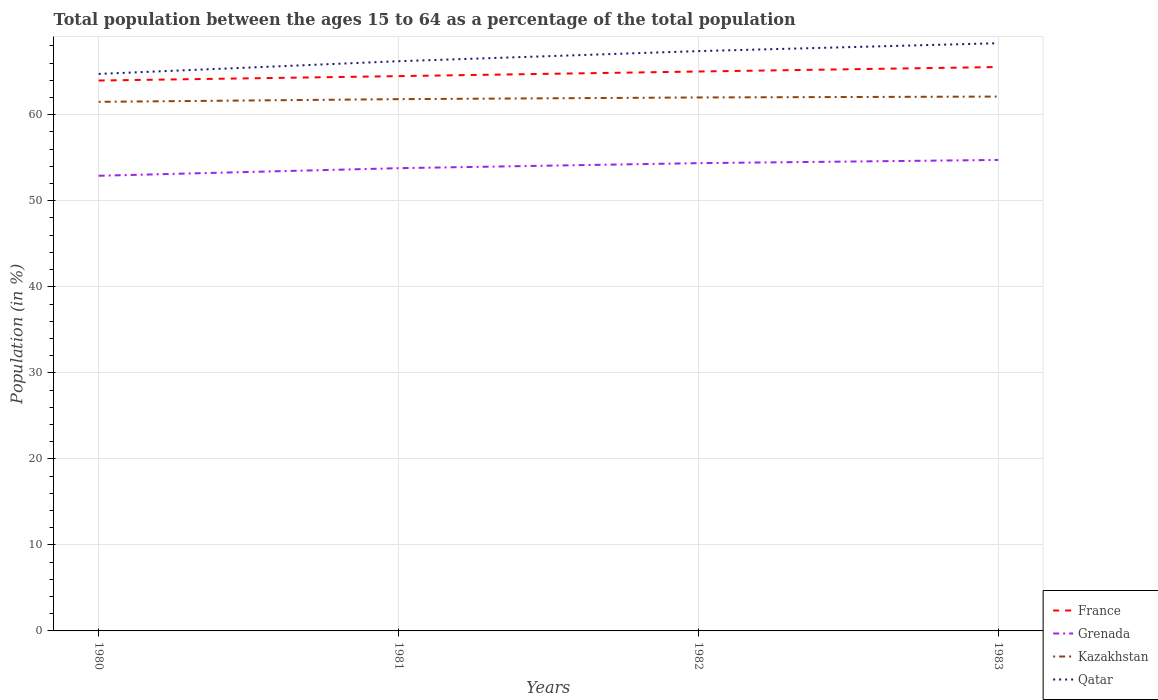Is the number of lines equal to the number of legend labels?
Provide a short and direct response. Yes. Across all years, what is the maximum percentage of the population ages 15 to 64 in Kazakhstan?
Your response must be concise. 61.5. In which year was the percentage of the population ages 15 to 64 in Kazakhstan maximum?
Offer a terse response. 1980. What is the total percentage of the population ages 15 to 64 in Kazakhstan in the graph?
Give a very brief answer. -0.2. What is the difference between the highest and the second highest percentage of the population ages 15 to 64 in Qatar?
Provide a short and direct response. 3.57. Does the graph contain any zero values?
Ensure brevity in your answer.  No. Does the graph contain grids?
Provide a short and direct response. Yes. Where does the legend appear in the graph?
Your response must be concise. Bottom right. How many legend labels are there?
Ensure brevity in your answer.  4. What is the title of the graph?
Offer a terse response. Total population between the ages 15 to 64 as a percentage of the total population. Does "Portugal" appear as one of the legend labels in the graph?
Keep it short and to the point. No. What is the Population (in %) in France in 1980?
Keep it short and to the point. 63.98. What is the Population (in %) in Grenada in 1980?
Provide a short and direct response. 52.91. What is the Population (in %) of Kazakhstan in 1980?
Make the answer very short. 61.5. What is the Population (in %) of Qatar in 1980?
Your response must be concise. 64.75. What is the Population (in %) of France in 1981?
Provide a short and direct response. 64.49. What is the Population (in %) in Grenada in 1981?
Ensure brevity in your answer.  53.79. What is the Population (in %) in Kazakhstan in 1981?
Offer a terse response. 61.81. What is the Population (in %) of Qatar in 1981?
Offer a terse response. 66.22. What is the Population (in %) of France in 1982?
Your answer should be very brief. 65.03. What is the Population (in %) in Grenada in 1982?
Your answer should be compact. 54.37. What is the Population (in %) of Kazakhstan in 1982?
Offer a terse response. 62.01. What is the Population (in %) in Qatar in 1982?
Your answer should be very brief. 67.4. What is the Population (in %) in France in 1983?
Your answer should be very brief. 65.55. What is the Population (in %) of Grenada in 1983?
Offer a very short reply. 54.75. What is the Population (in %) in Kazakhstan in 1983?
Provide a short and direct response. 62.11. What is the Population (in %) in Qatar in 1983?
Your answer should be very brief. 68.32. Across all years, what is the maximum Population (in %) in France?
Give a very brief answer. 65.55. Across all years, what is the maximum Population (in %) in Grenada?
Offer a terse response. 54.75. Across all years, what is the maximum Population (in %) in Kazakhstan?
Make the answer very short. 62.11. Across all years, what is the maximum Population (in %) of Qatar?
Offer a terse response. 68.32. Across all years, what is the minimum Population (in %) in France?
Keep it short and to the point. 63.98. Across all years, what is the minimum Population (in %) in Grenada?
Offer a terse response. 52.91. Across all years, what is the minimum Population (in %) in Kazakhstan?
Your answer should be compact. 61.5. Across all years, what is the minimum Population (in %) in Qatar?
Your answer should be very brief. 64.75. What is the total Population (in %) in France in the graph?
Your response must be concise. 259.04. What is the total Population (in %) in Grenada in the graph?
Keep it short and to the point. 215.82. What is the total Population (in %) in Kazakhstan in the graph?
Provide a succinct answer. 247.44. What is the total Population (in %) in Qatar in the graph?
Provide a short and direct response. 266.69. What is the difference between the Population (in %) of France in 1980 and that in 1981?
Your answer should be very brief. -0.51. What is the difference between the Population (in %) in Grenada in 1980 and that in 1981?
Your answer should be very brief. -0.88. What is the difference between the Population (in %) of Kazakhstan in 1980 and that in 1981?
Provide a succinct answer. -0.31. What is the difference between the Population (in %) in Qatar in 1980 and that in 1981?
Your answer should be very brief. -1.48. What is the difference between the Population (in %) in France in 1980 and that in 1982?
Give a very brief answer. -1.05. What is the difference between the Population (in %) of Grenada in 1980 and that in 1982?
Offer a very short reply. -1.47. What is the difference between the Population (in %) in Kazakhstan in 1980 and that in 1982?
Offer a very short reply. -0.51. What is the difference between the Population (in %) of Qatar in 1980 and that in 1982?
Your response must be concise. -2.65. What is the difference between the Population (in %) of France in 1980 and that in 1983?
Your response must be concise. -1.57. What is the difference between the Population (in %) of Grenada in 1980 and that in 1983?
Ensure brevity in your answer.  -1.84. What is the difference between the Population (in %) in Kazakhstan in 1980 and that in 1983?
Make the answer very short. -0.61. What is the difference between the Population (in %) of Qatar in 1980 and that in 1983?
Provide a succinct answer. -3.57. What is the difference between the Population (in %) of France in 1981 and that in 1982?
Keep it short and to the point. -0.54. What is the difference between the Population (in %) of Grenada in 1981 and that in 1982?
Your response must be concise. -0.59. What is the difference between the Population (in %) in Kazakhstan in 1981 and that in 1982?
Your response must be concise. -0.2. What is the difference between the Population (in %) of Qatar in 1981 and that in 1982?
Make the answer very short. -1.17. What is the difference between the Population (in %) of France in 1981 and that in 1983?
Provide a succinct answer. -1.06. What is the difference between the Population (in %) of Grenada in 1981 and that in 1983?
Offer a very short reply. -0.96. What is the difference between the Population (in %) of Kazakhstan in 1981 and that in 1983?
Your answer should be very brief. -0.3. What is the difference between the Population (in %) in Qatar in 1981 and that in 1983?
Your answer should be very brief. -2.09. What is the difference between the Population (in %) of France in 1982 and that in 1983?
Give a very brief answer. -0.52. What is the difference between the Population (in %) of Grenada in 1982 and that in 1983?
Offer a terse response. -0.37. What is the difference between the Population (in %) in Kazakhstan in 1982 and that in 1983?
Offer a very short reply. -0.1. What is the difference between the Population (in %) of Qatar in 1982 and that in 1983?
Give a very brief answer. -0.92. What is the difference between the Population (in %) of France in 1980 and the Population (in %) of Grenada in 1981?
Your answer should be compact. 10.19. What is the difference between the Population (in %) in France in 1980 and the Population (in %) in Kazakhstan in 1981?
Provide a short and direct response. 2.16. What is the difference between the Population (in %) in France in 1980 and the Population (in %) in Qatar in 1981?
Make the answer very short. -2.25. What is the difference between the Population (in %) in Grenada in 1980 and the Population (in %) in Kazakhstan in 1981?
Keep it short and to the point. -8.91. What is the difference between the Population (in %) of Grenada in 1980 and the Population (in %) of Qatar in 1981?
Provide a succinct answer. -13.32. What is the difference between the Population (in %) of Kazakhstan in 1980 and the Population (in %) of Qatar in 1981?
Make the answer very short. -4.72. What is the difference between the Population (in %) in France in 1980 and the Population (in %) in Grenada in 1982?
Make the answer very short. 9.6. What is the difference between the Population (in %) of France in 1980 and the Population (in %) of Kazakhstan in 1982?
Keep it short and to the point. 1.97. What is the difference between the Population (in %) in France in 1980 and the Population (in %) in Qatar in 1982?
Keep it short and to the point. -3.42. What is the difference between the Population (in %) in Grenada in 1980 and the Population (in %) in Kazakhstan in 1982?
Your response must be concise. -9.1. What is the difference between the Population (in %) of Grenada in 1980 and the Population (in %) of Qatar in 1982?
Your answer should be very brief. -14.49. What is the difference between the Population (in %) of Kazakhstan in 1980 and the Population (in %) of Qatar in 1982?
Your answer should be compact. -5.9. What is the difference between the Population (in %) in France in 1980 and the Population (in %) in Grenada in 1983?
Your answer should be compact. 9.23. What is the difference between the Population (in %) in France in 1980 and the Population (in %) in Kazakhstan in 1983?
Provide a short and direct response. 1.86. What is the difference between the Population (in %) in France in 1980 and the Population (in %) in Qatar in 1983?
Your answer should be compact. -4.34. What is the difference between the Population (in %) in Grenada in 1980 and the Population (in %) in Kazakhstan in 1983?
Your response must be concise. -9.21. What is the difference between the Population (in %) in Grenada in 1980 and the Population (in %) in Qatar in 1983?
Offer a very short reply. -15.41. What is the difference between the Population (in %) in Kazakhstan in 1980 and the Population (in %) in Qatar in 1983?
Keep it short and to the point. -6.81. What is the difference between the Population (in %) of France in 1981 and the Population (in %) of Grenada in 1982?
Provide a short and direct response. 10.12. What is the difference between the Population (in %) in France in 1981 and the Population (in %) in Kazakhstan in 1982?
Give a very brief answer. 2.48. What is the difference between the Population (in %) in France in 1981 and the Population (in %) in Qatar in 1982?
Make the answer very short. -2.91. What is the difference between the Population (in %) of Grenada in 1981 and the Population (in %) of Kazakhstan in 1982?
Provide a succinct answer. -8.22. What is the difference between the Population (in %) of Grenada in 1981 and the Population (in %) of Qatar in 1982?
Your answer should be very brief. -13.61. What is the difference between the Population (in %) of Kazakhstan in 1981 and the Population (in %) of Qatar in 1982?
Offer a very short reply. -5.58. What is the difference between the Population (in %) of France in 1981 and the Population (in %) of Grenada in 1983?
Provide a short and direct response. 9.74. What is the difference between the Population (in %) in France in 1981 and the Population (in %) in Kazakhstan in 1983?
Your response must be concise. 2.38. What is the difference between the Population (in %) in France in 1981 and the Population (in %) in Qatar in 1983?
Provide a short and direct response. -3.83. What is the difference between the Population (in %) in Grenada in 1981 and the Population (in %) in Kazakhstan in 1983?
Provide a short and direct response. -8.32. What is the difference between the Population (in %) of Grenada in 1981 and the Population (in %) of Qatar in 1983?
Your response must be concise. -14.53. What is the difference between the Population (in %) of Kazakhstan in 1981 and the Population (in %) of Qatar in 1983?
Offer a terse response. -6.5. What is the difference between the Population (in %) in France in 1982 and the Population (in %) in Grenada in 1983?
Your answer should be compact. 10.28. What is the difference between the Population (in %) of France in 1982 and the Population (in %) of Kazakhstan in 1983?
Keep it short and to the point. 2.91. What is the difference between the Population (in %) of France in 1982 and the Population (in %) of Qatar in 1983?
Provide a short and direct response. -3.29. What is the difference between the Population (in %) of Grenada in 1982 and the Population (in %) of Kazakhstan in 1983?
Keep it short and to the point. -7.74. What is the difference between the Population (in %) in Grenada in 1982 and the Population (in %) in Qatar in 1983?
Make the answer very short. -13.94. What is the difference between the Population (in %) of Kazakhstan in 1982 and the Population (in %) of Qatar in 1983?
Keep it short and to the point. -6.31. What is the average Population (in %) of France per year?
Make the answer very short. 64.76. What is the average Population (in %) of Grenada per year?
Your answer should be compact. 53.95. What is the average Population (in %) in Kazakhstan per year?
Your response must be concise. 61.86. What is the average Population (in %) in Qatar per year?
Offer a very short reply. 66.67. In the year 1980, what is the difference between the Population (in %) in France and Population (in %) in Grenada?
Ensure brevity in your answer.  11.07. In the year 1980, what is the difference between the Population (in %) in France and Population (in %) in Kazakhstan?
Make the answer very short. 2.48. In the year 1980, what is the difference between the Population (in %) in France and Population (in %) in Qatar?
Offer a terse response. -0.77. In the year 1980, what is the difference between the Population (in %) in Grenada and Population (in %) in Kazakhstan?
Make the answer very short. -8.6. In the year 1980, what is the difference between the Population (in %) in Grenada and Population (in %) in Qatar?
Provide a short and direct response. -11.84. In the year 1980, what is the difference between the Population (in %) in Kazakhstan and Population (in %) in Qatar?
Offer a very short reply. -3.24. In the year 1981, what is the difference between the Population (in %) in France and Population (in %) in Grenada?
Offer a terse response. 10.7. In the year 1981, what is the difference between the Population (in %) of France and Population (in %) of Kazakhstan?
Your answer should be very brief. 2.68. In the year 1981, what is the difference between the Population (in %) in France and Population (in %) in Qatar?
Your answer should be very brief. -1.73. In the year 1981, what is the difference between the Population (in %) in Grenada and Population (in %) in Kazakhstan?
Your answer should be compact. -8.02. In the year 1981, what is the difference between the Population (in %) of Grenada and Population (in %) of Qatar?
Ensure brevity in your answer.  -12.43. In the year 1981, what is the difference between the Population (in %) of Kazakhstan and Population (in %) of Qatar?
Provide a succinct answer. -4.41. In the year 1982, what is the difference between the Population (in %) in France and Population (in %) in Grenada?
Offer a terse response. 10.65. In the year 1982, what is the difference between the Population (in %) of France and Population (in %) of Kazakhstan?
Offer a terse response. 3.02. In the year 1982, what is the difference between the Population (in %) of France and Population (in %) of Qatar?
Offer a very short reply. -2.37. In the year 1982, what is the difference between the Population (in %) of Grenada and Population (in %) of Kazakhstan?
Give a very brief answer. -7.64. In the year 1982, what is the difference between the Population (in %) of Grenada and Population (in %) of Qatar?
Provide a succinct answer. -13.02. In the year 1982, what is the difference between the Population (in %) in Kazakhstan and Population (in %) in Qatar?
Ensure brevity in your answer.  -5.39. In the year 1983, what is the difference between the Population (in %) in France and Population (in %) in Grenada?
Your answer should be compact. 10.8. In the year 1983, what is the difference between the Population (in %) of France and Population (in %) of Kazakhstan?
Provide a succinct answer. 3.43. In the year 1983, what is the difference between the Population (in %) of France and Population (in %) of Qatar?
Offer a terse response. -2.77. In the year 1983, what is the difference between the Population (in %) in Grenada and Population (in %) in Kazakhstan?
Provide a short and direct response. -7.37. In the year 1983, what is the difference between the Population (in %) of Grenada and Population (in %) of Qatar?
Provide a short and direct response. -13.57. In the year 1983, what is the difference between the Population (in %) of Kazakhstan and Population (in %) of Qatar?
Your answer should be very brief. -6.2. What is the ratio of the Population (in %) in France in 1980 to that in 1981?
Keep it short and to the point. 0.99. What is the ratio of the Population (in %) in Grenada in 1980 to that in 1981?
Keep it short and to the point. 0.98. What is the ratio of the Population (in %) of Qatar in 1980 to that in 1981?
Your response must be concise. 0.98. What is the ratio of the Population (in %) of France in 1980 to that in 1982?
Provide a succinct answer. 0.98. What is the ratio of the Population (in %) of Grenada in 1980 to that in 1982?
Your answer should be very brief. 0.97. What is the ratio of the Population (in %) in Kazakhstan in 1980 to that in 1982?
Your answer should be very brief. 0.99. What is the ratio of the Population (in %) in Qatar in 1980 to that in 1982?
Your answer should be compact. 0.96. What is the ratio of the Population (in %) of France in 1980 to that in 1983?
Make the answer very short. 0.98. What is the ratio of the Population (in %) of Grenada in 1980 to that in 1983?
Offer a very short reply. 0.97. What is the ratio of the Population (in %) of Kazakhstan in 1980 to that in 1983?
Ensure brevity in your answer.  0.99. What is the ratio of the Population (in %) in Qatar in 1980 to that in 1983?
Make the answer very short. 0.95. What is the ratio of the Population (in %) of Qatar in 1981 to that in 1982?
Give a very brief answer. 0.98. What is the ratio of the Population (in %) in France in 1981 to that in 1983?
Your answer should be compact. 0.98. What is the ratio of the Population (in %) in Grenada in 1981 to that in 1983?
Offer a very short reply. 0.98. What is the ratio of the Population (in %) in Kazakhstan in 1981 to that in 1983?
Your answer should be compact. 1. What is the ratio of the Population (in %) of Qatar in 1981 to that in 1983?
Offer a terse response. 0.97. What is the ratio of the Population (in %) in France in 1982 to that in 1983?
Your answer should be very brief. 0.99. What is the ratio of the Population (in %) in Qatar in 1982 to that in 1983?
Your response must be concise. 0.99. What is the difference between the highest and the second highest Population (in %) in France?
Keep it short and to the point. 0.52. What is the difference between the highest and the second highest Population (in %) in Grenada?
Make the answer very short. 0.37. What is the difference between the highest and the second highest Population (in %) of Kazakhstan?
Ensure brevity in your answer.  0.1. What is the difference between the highest and the second highest Population (in %) of Qatar?
Offer a terse response. 0.92. What is the difference between the highest and the lowest Population (in %) in France?
Provide a succinct answer. 1.57. What is the difference between the highest and the lowest Population (in %) in Grenada?
Provide a short and direct response. 1.84. What is the difference between the highest and the lowest Population (in %) in Kazakhstan?
Make the answer very short. 0.61. What is the difference between the highest and the lowest Population (in %) in Qatar?
Provide a short and direct response. 3.57. 